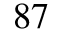<formula> <loc_0><loc_0><loc_500><loc_500>{ } ^ { 8 7 }</formula> 